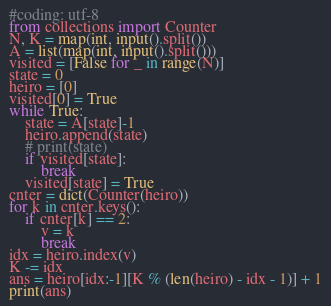<code> <loc_0><loc_0><loc_500><loc_500><_Python_>#coding: utf-8
from collections import Counter
N, K = map(int, input().split())
A = list(map(int, input().split()))
visited = [False for _ in range(N)]
state = 0
heiro = [0]
visited[0] = True
while True:
    state = A[state]-1
    heiro.append(state)
    # print(state)
    if visited[state]:
        break
    visited[state] = True
cnter = dict(Counter(heiro))
for k in cnter.keys():
    if cnter[k] == 2:
        v = k
        break
idx = heiro.index(v)
K -= idx
ans = heiro[idx:-1][K % (len(heiro) - idx - 1)] + 1
print(ans)</code> 